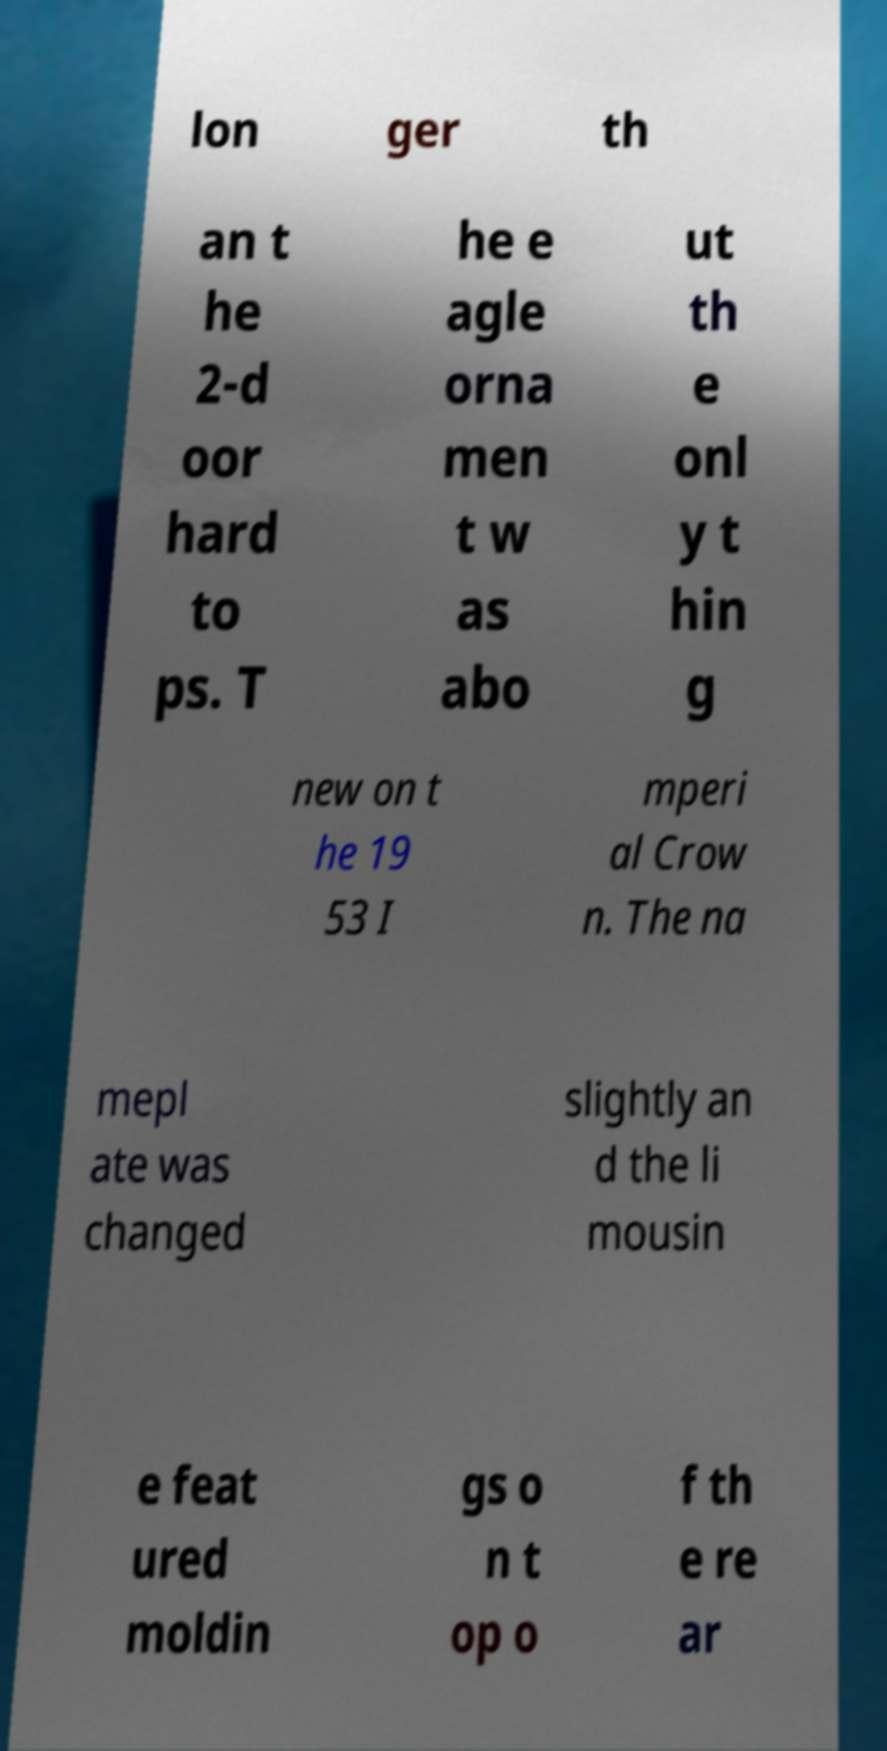I need the written content from this picture converted into text. Can you do that? lon ger th an t he 2-d oor hard to ps. T he e agle orna men t w as abo ut th e onl y t hin g new on t he 19 53 I mperi al Crow n. The na mepl ate was changed slightly an d the li mousin e feat ured moldin gs o n t op o f th e re ar 